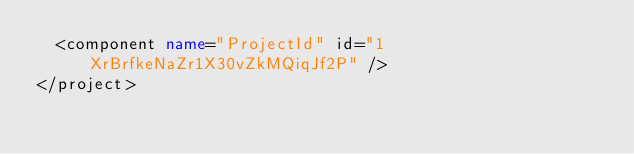<code> <loc_0><loc_0><loc_500><loc_500><_XML_>  <component name="ProjectId" id="1XrBrfkeNaZr1X30vZkMQiqJf2P" />
</project></code> 